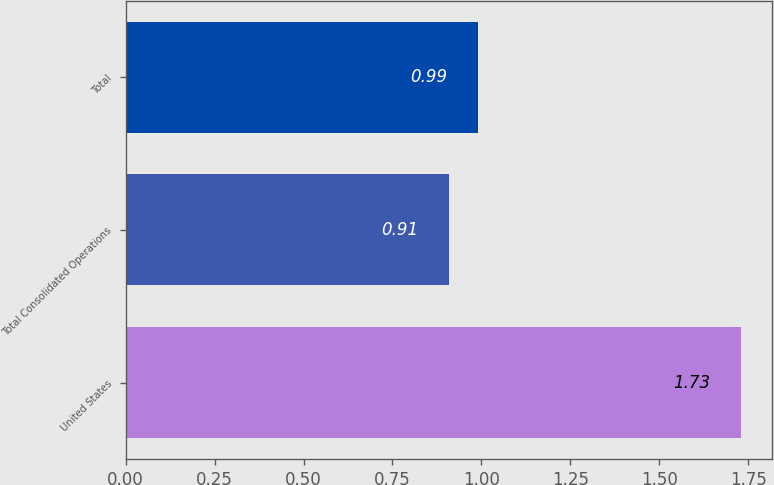Convert chart to OTSL. <chart><loc_0><loc_0><loc_500><loc_500><bar_chart><fcel>United States<fcel>Total Consolidated Operations<fcel>Total<nl><fcel>1.73<fcel>0.91<fcel>0.99<nl></chart> 